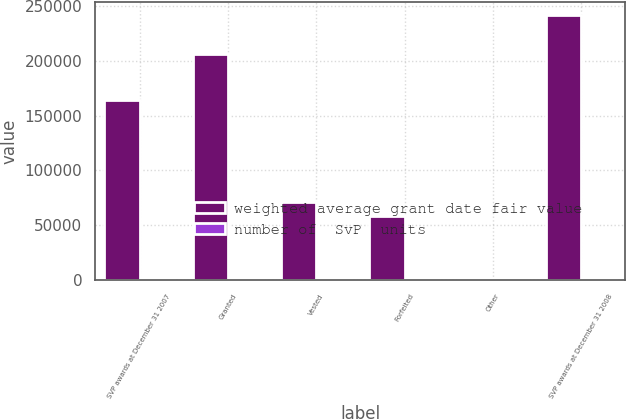<chart> <loc_0><loc_0><loc_500><loc_500><stacked_bar_chart><ecel><fcel>SVP awards at December 31 2007<fcel>Granted<fcel>Vested<fcel>Forfeited<fcel>Other<fcel>SVP awards at December 31 2008<nl><fcel>weighted average grant date fair value<fcel>164180<fcel>206578<fcel>70847<fcel>57835<fcel>383<fcel>241693<nl><fcel>number of  SvP  units<fcel>40.2<fcel>23.34<fcel>34.17<fcel>30.96<fcel>30.71<fcel>29.78<nl></chart> 